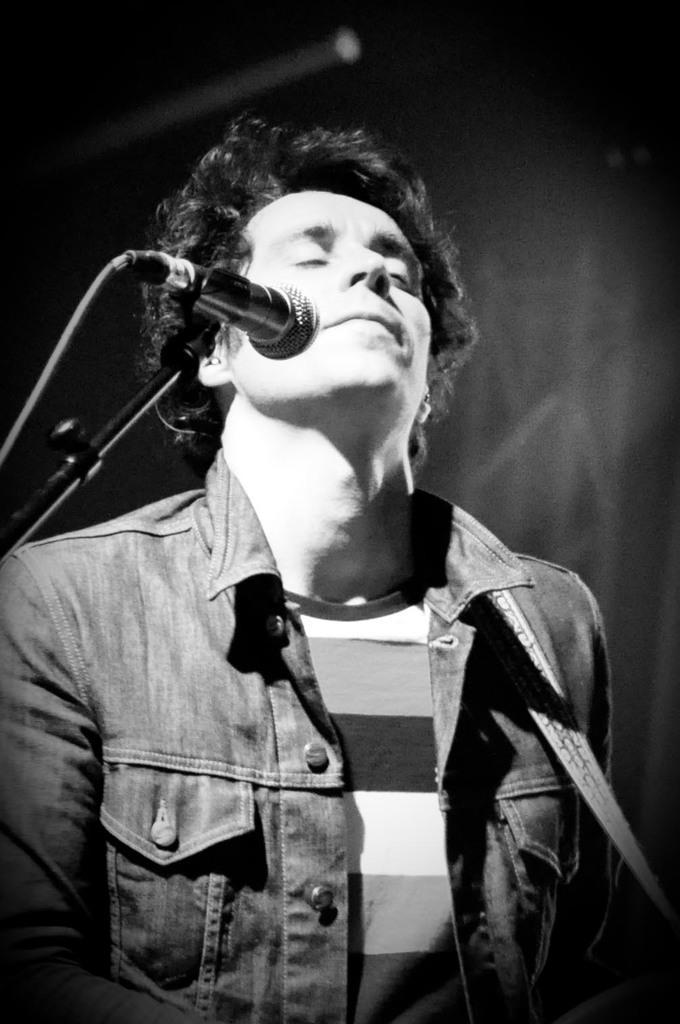In one or two sentences, can you explain what this image depicts? In this image there is a man standing in front of microphone with closed eyes. 